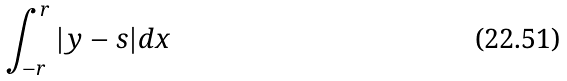<formula> <loc_0><loc_0><loc_500><loc_500>\int _ { - r } ^ { r } | y - s | d x</formula> 